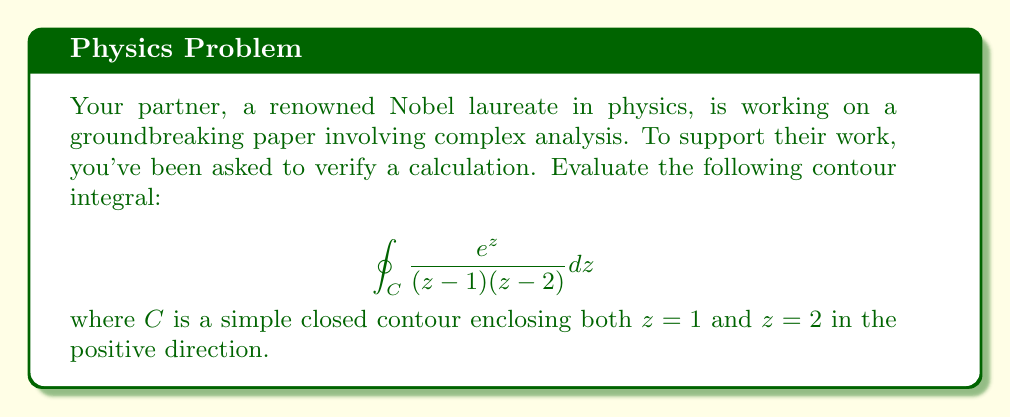Can you answer this question? To solve this problem, we'll use Cauchy's Integral Formula for multiple poles. The steps are as follows:

1) First, identify the poles of the integrand. In this case, we have simple poles at $z=1$ and $z=2$.

2) The general form of Cauchy's Integral Formula for multiple poles is:

   $$\oint_C \frac{f(z)}{(z-a_1)(z-a_2)...(z-a_n)} dz = 2\pi i \sum_{k=1}^n \frac{f(a_k)}{\prod_{j\neq k} (a_k-a_j)}$$

3) In our case, $f(z) = e^z$, $a_1 = 1$, and $a_2 = 2$. Let's apply the formula:

   $$\oint_C \frac{e^z}{(z-1)(z-2)} dz = 2\pi i \left[\frac{e^1}{1-2} + \frac{e^2}{2-1}\right]$$

4) Simplify:
   $$= 2\pi i \left[-e + e^2\right]$$

5) Factor out $e$:
   $$= 2\pi i e(e-1)$$

This is our final result.
Answer: $2\pi i e(e-1)$ 